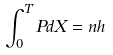<formula> <loc_0><loc_0><loc_500><loc_500>\int _ { 0 } ^ { T } P d X = n h</formula> 